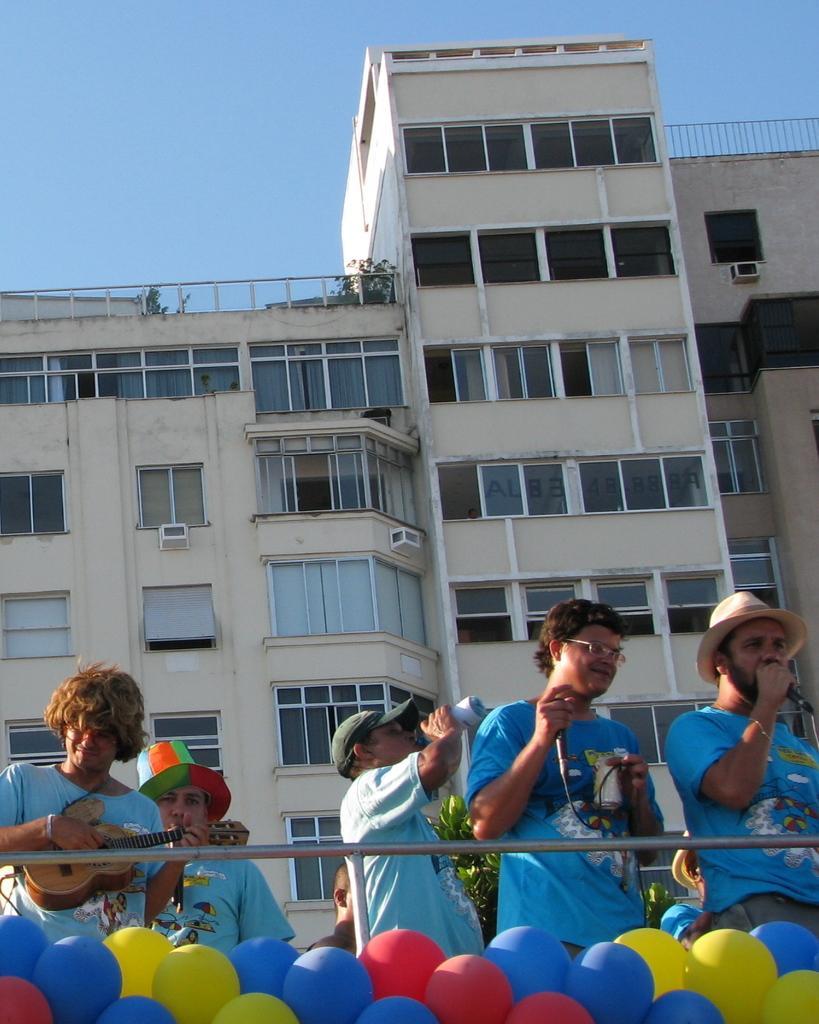How would you summarize this image in a sentence or two? This image is clicked outside the house. There are six persons in the image. All are wearing blue t-shirts. In the background there is a building. To which there are many windows and ventilators. At the top, there is a sky in blue color. 